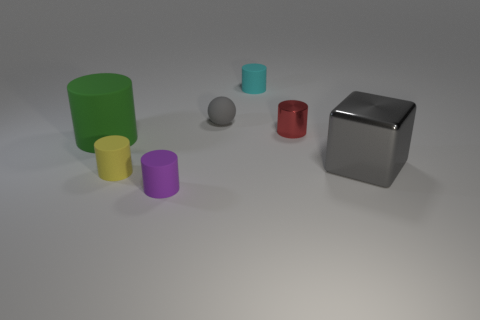What number of things are either green metal things or small red objects?
Give a very brief answer. 1. The large object that is right of the tiny gray matte ball that is on the right side of the large rubber cylinder is made of what material?
Your response must be concise. Metal. What number of blue things are the same shape as the small purple object?
Offer a very short reply. 0. Is there a large cylinder of the same color as the cube?
Make the answer very short. No. What number of objects are gray things in front of the green matte cylinder or objects that are in front of the small cyan matte cylinder?
Provide a succinct answer. 6. There is a gray object to the left of the small red object; is there a tiny cylinder right of it?
Make the answer very short. Yes. There is a green object that is the same size as the gray cube; what is its shape?
Ensure brevity in your answer.  Cylinder. What number of objects are either tiny objects behind the small red metallic cylinder or large gray cubes?
Offer a very short reply. 3. What number of other things are there of the same material as the big cylinder
Offer a very short reply. 4. There is a small object that is the same color as the big shiny cube; what shape is it?
Provide a short and direct response. Sphere. 